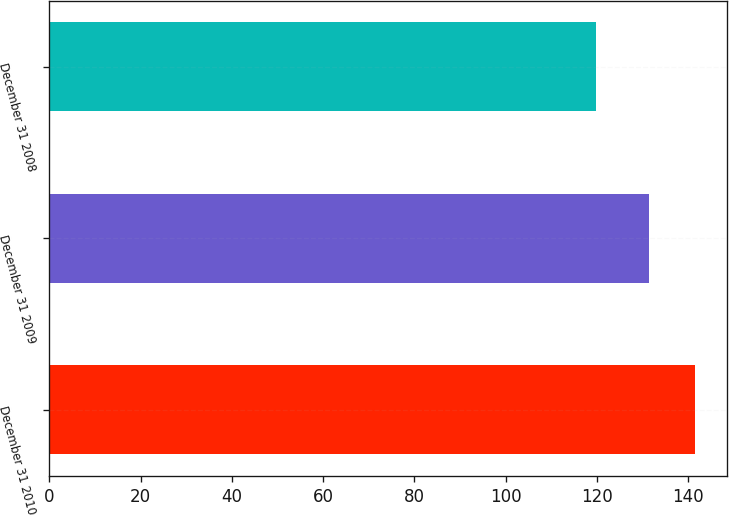Convert chart. <chart><loc_0><loc_0><loc_500><loc_500><bar_chart><fcel>December 31 2010<fcel>December 31 2009<fcel>December 31 2008<nl><fcel>141.4<fcel>131.5<fcel>119.7<nl></chart> 